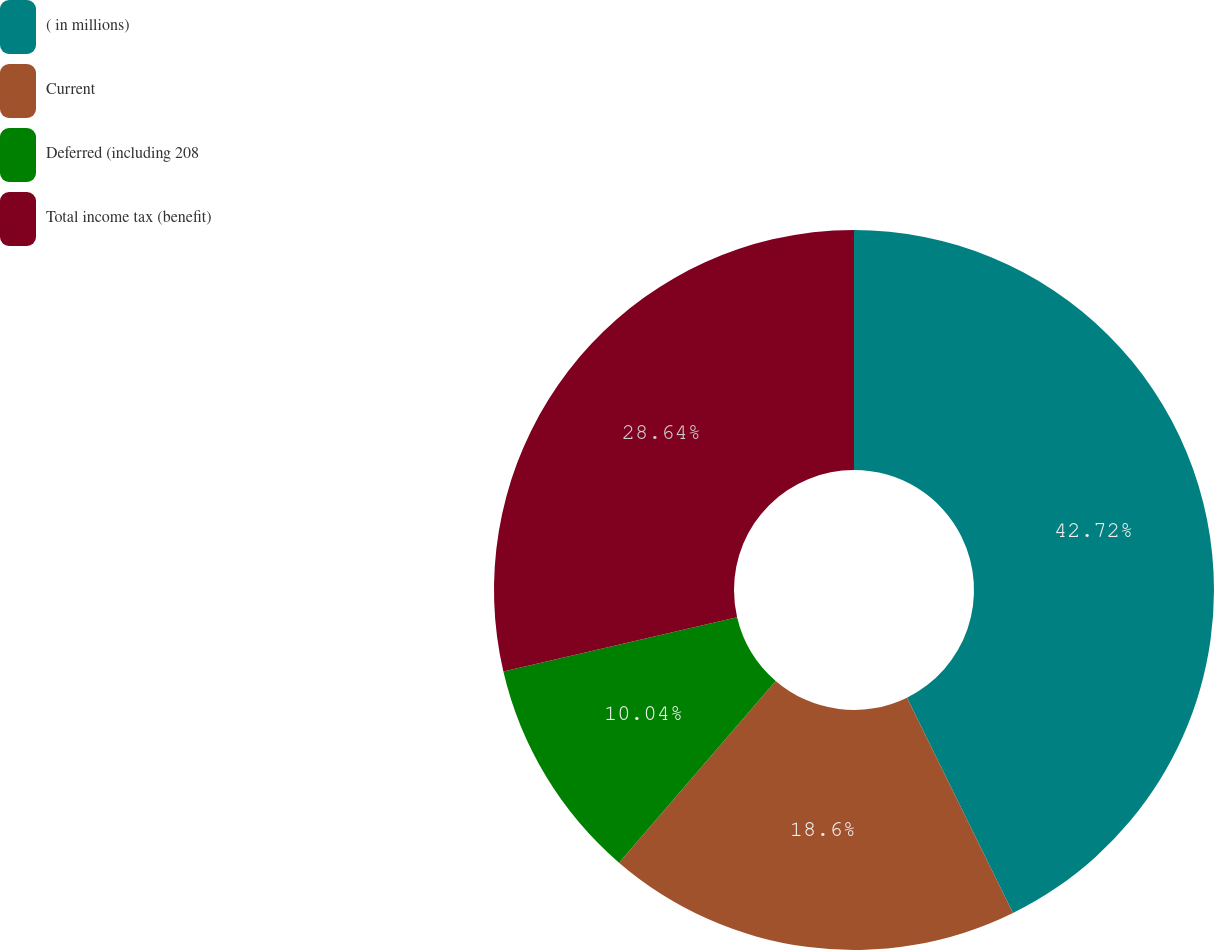Convert chart. <chart><loc_0><loc_0><loc_500><loc_500><pie_chart><fcel>( in millions)<fcel>Current<fcel>Deferred (including 208<fcel>Total income tax (benefit)<nl><fcel>42.72%<fcel>18.6%<fcel>10.04%<fcel>28.64%<nl></chart> 